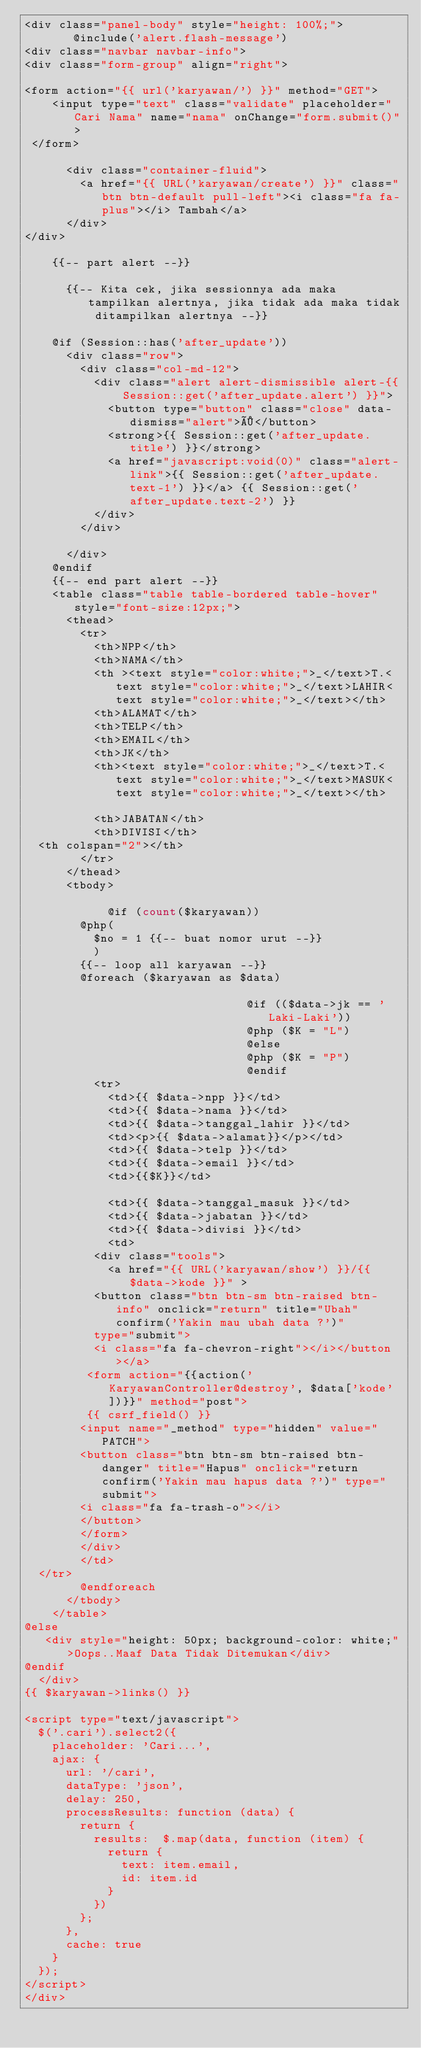<code> <loc_0><loc_0><loc_500><loc_500><_PHP_><div class="panel-body" style="height: 100%;">
       @include('alert.flash-message')
<div class="navbar navbar-info">
<div class="form-group" align="right">

<form action="{{ url('karyawan/') }}" method="GET">
    <input type="text" class="validate" placeholder="Cari Nama" name="nama" onChange="form.submit()">
 </form>

      <div class="container-fluid">
        <a href="{{ URL('karyawan/create') }}" class="btn btn-default pull-left"><i class="fa fa-plus"></i> Tambah</a>
      </div>
</div>

    {{-- part alert --}}
    
      {{-- Kita cek, jika sessionnya ada maka tampilkan alertnya, jika tidak ada maka tidak ditampilkan alertnya --}}
    
    @if (Session::has('after_update'))
      <div class="row">
        <div class="col-md-12">
          <div class="alert alert-dismissible alert-{{ Session::get('after_update.alert') }}">
            <button type="button" class="close" data-dismiss="alert">×</button>
            <strong>{{ Session::get('after_update.title') }}</strong>
            <a href="javascript:void(0)" class="alert-link">{{ Session::get('after_update.text-1') }}</a> {{ Session::get('after_update.text-2') }}
          </div>
        </div>
                            
      </div>
    @endif
    {{-- end part alert --}}
    <table class="table table-bordered table-hover" style="font-size:12px;">
      <thead>
        <tr>
          <th>NPP</th>
          <th>NAMA</th>
          <th ><text style="color:white;">_</text>T.<text style="color:white;">_</text>LAHIR<text style="color:white;">_</text></th>
          <th>ALAMAT</th>
          <th>TELP</th>
          <th>EMAIL</th>
          <th>JK</th>
          <th><text style="color:white;">_</text>T.<text style="color:white;">_</text>MASUK<text style="color:white;">_</text></th>
          
          <th>JABATAN</th>
          <th>DIVISI</th>
  <th colspan="2"></th>
        </tr>
      </thead>
      <tbody>
                            
            @if (count($karyawan))
        @php(
          $no = 1 {{-- buat nomor urut --}}
          )
        {{-- loop all karyawan --}}
        @foreach ($karyawan as $data)
                                
                                @if (($data->jk == 'Laki-Laki'))
                                @php ($K = "L")
                                @else
                                @php ($K = "P")
                                @endif
          <tr>
            <td>{{ $data->npp }}</td>
            <td>{{ $data->nama }}</td>
            <td>{{ $data->tanggal_lahir }}</td>
            <td><p>{{ $data->alamat}}</p></td>
            <td>{{ $data->telp }}</td>
            <td>{{ $data->email }}</td>
            <td>{{$K}}</td>
            
            <td>{{ $data->tanggal_masuk }}</td>
            <td>{{ $data->jabatan }}</td>
            <td>{{ $data->divisi }}</td>
            <td>
          <div class="tools">
            <a href="{{ URL('karyawan/show') }}/{{ $data->kode }}" >
          <button class="btn btn-sm btn-raised btn-info" onclick="return" title="Ubah" confirm('Yakin mau ubah data ?')"
          type="submit">
          <i class="fa fa-chevron-right"></i></button></a>
         <form action="{{action('KaryawanController@destroy', $data['kode'])}}" method="post">
         {{ csrf_field() }}
        <input name="_method" type="hidden" value="PATCH">
        <button class="btn btn-sm btn-raised btn-danger" title="Hapus" onclick="return confirm('Yakin mau hapus data ?')" type="submit">
        <i class="fa fa-trash-o"></i>
        </button>
        </form>
        </div>
        </td>
  </tr>      
        @endforeach
      </tbody>
    </table>
@else
   <div style="height: 50px; background-color: white;">Oops..Maaf Data Tidak Ditemukan</div>
@endif
  </div>
{{ $karyawan->links() }}

<script type="text/javascript">
  $('.cari').select2({
    placeholder: 'Cari...',
    ajax: {
      url: '/cari',
      dataType: 'json',
      delay: 250,
      processResults: function (data) {
        return {
          results:  $.map(data, function (item) {
            return {
              text: item.email,
              id: item.id
            }
          })
        };
      },
      cache: true
    }
  });
</script>
</div></code> 